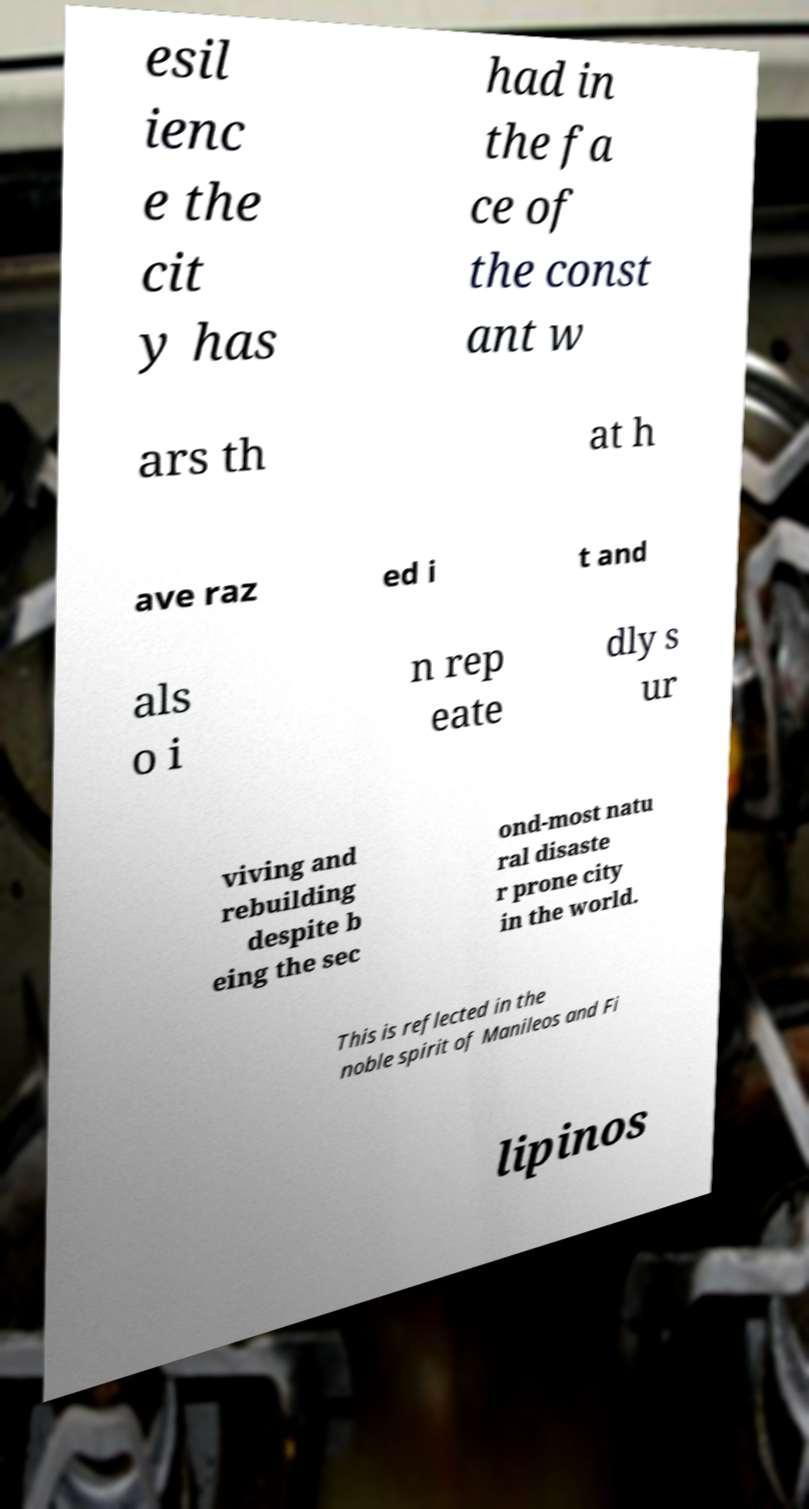Please read and relay the text visible in this image. What does it say? esil ienc e the cit y has had in the fa ce of the const ant w ars th at h ave raz ed i t and als o i n rep eate dly s ur viving and rebuilding despite b eing the sec ond-most natu ral disaste r prone city in the world. This is reflected in the noble spirit of Manileos and Fi lipinos 